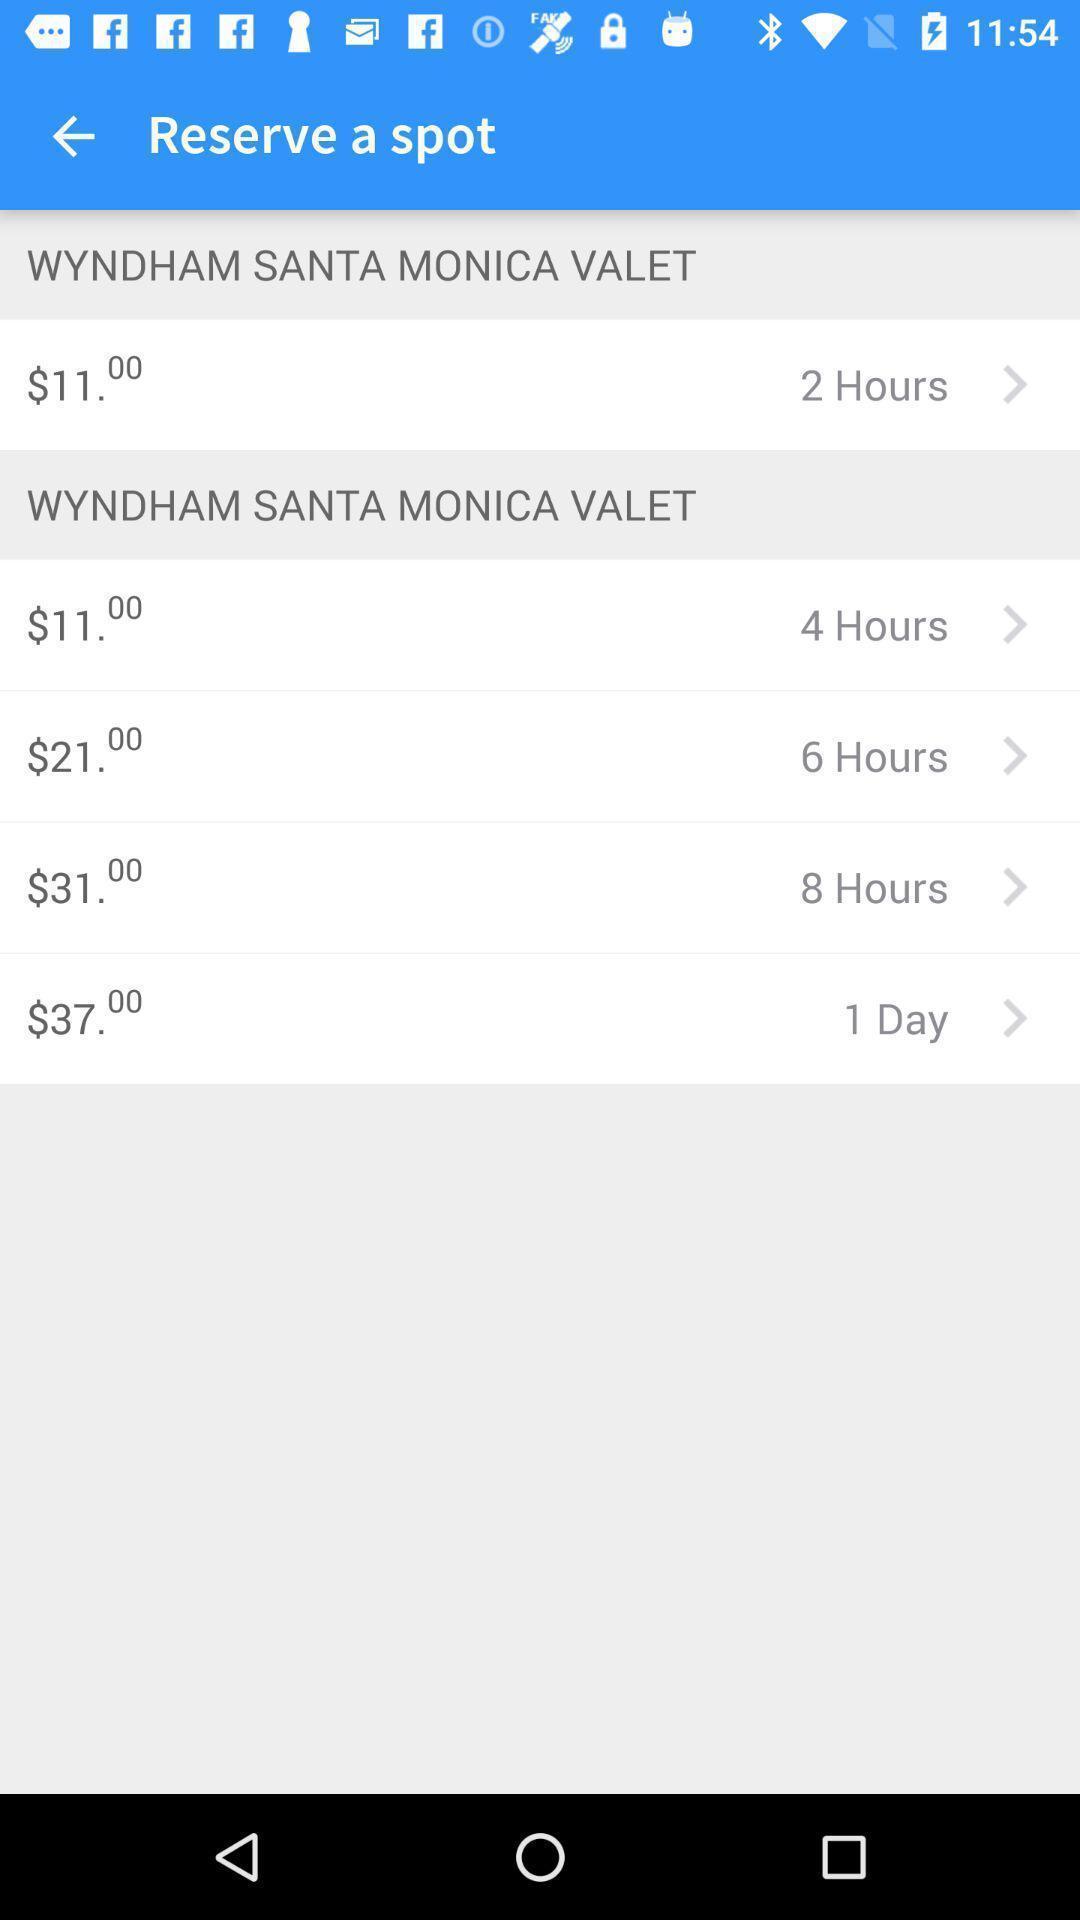Provide a description of this screenshot. Page to select a spot to reserve in parking app. 